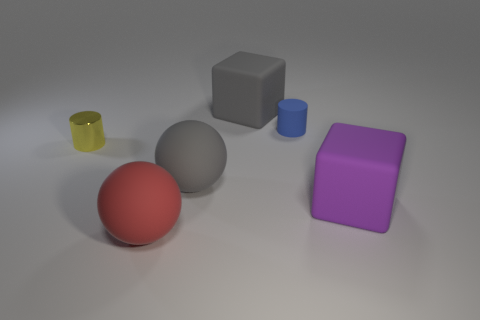Subtract all yellow cylinders. How many cylinders are left? 1 Add 3 gray metallic things. How many objects exist? 9 Subtract 1 blocks. How many blocks are left? 1 Subtract all cylinders. How many objects are left? 4 Subtract all gray blocks. How many yellow cylinders are left? 1 Subtract 0 yellow spheres. How many objects are left? 6 Subtract all cyan blocks. Subtract all cyan spheres. How many blocks are left? 2 Subtract all blue things. Subtract all gray rubber things. How many objects are left? 3 Add 1 purple rubber cubes. How many purple rubber cubes are left? 2 Add 1 large metal spheres. How many large metal spheres exist? 1 